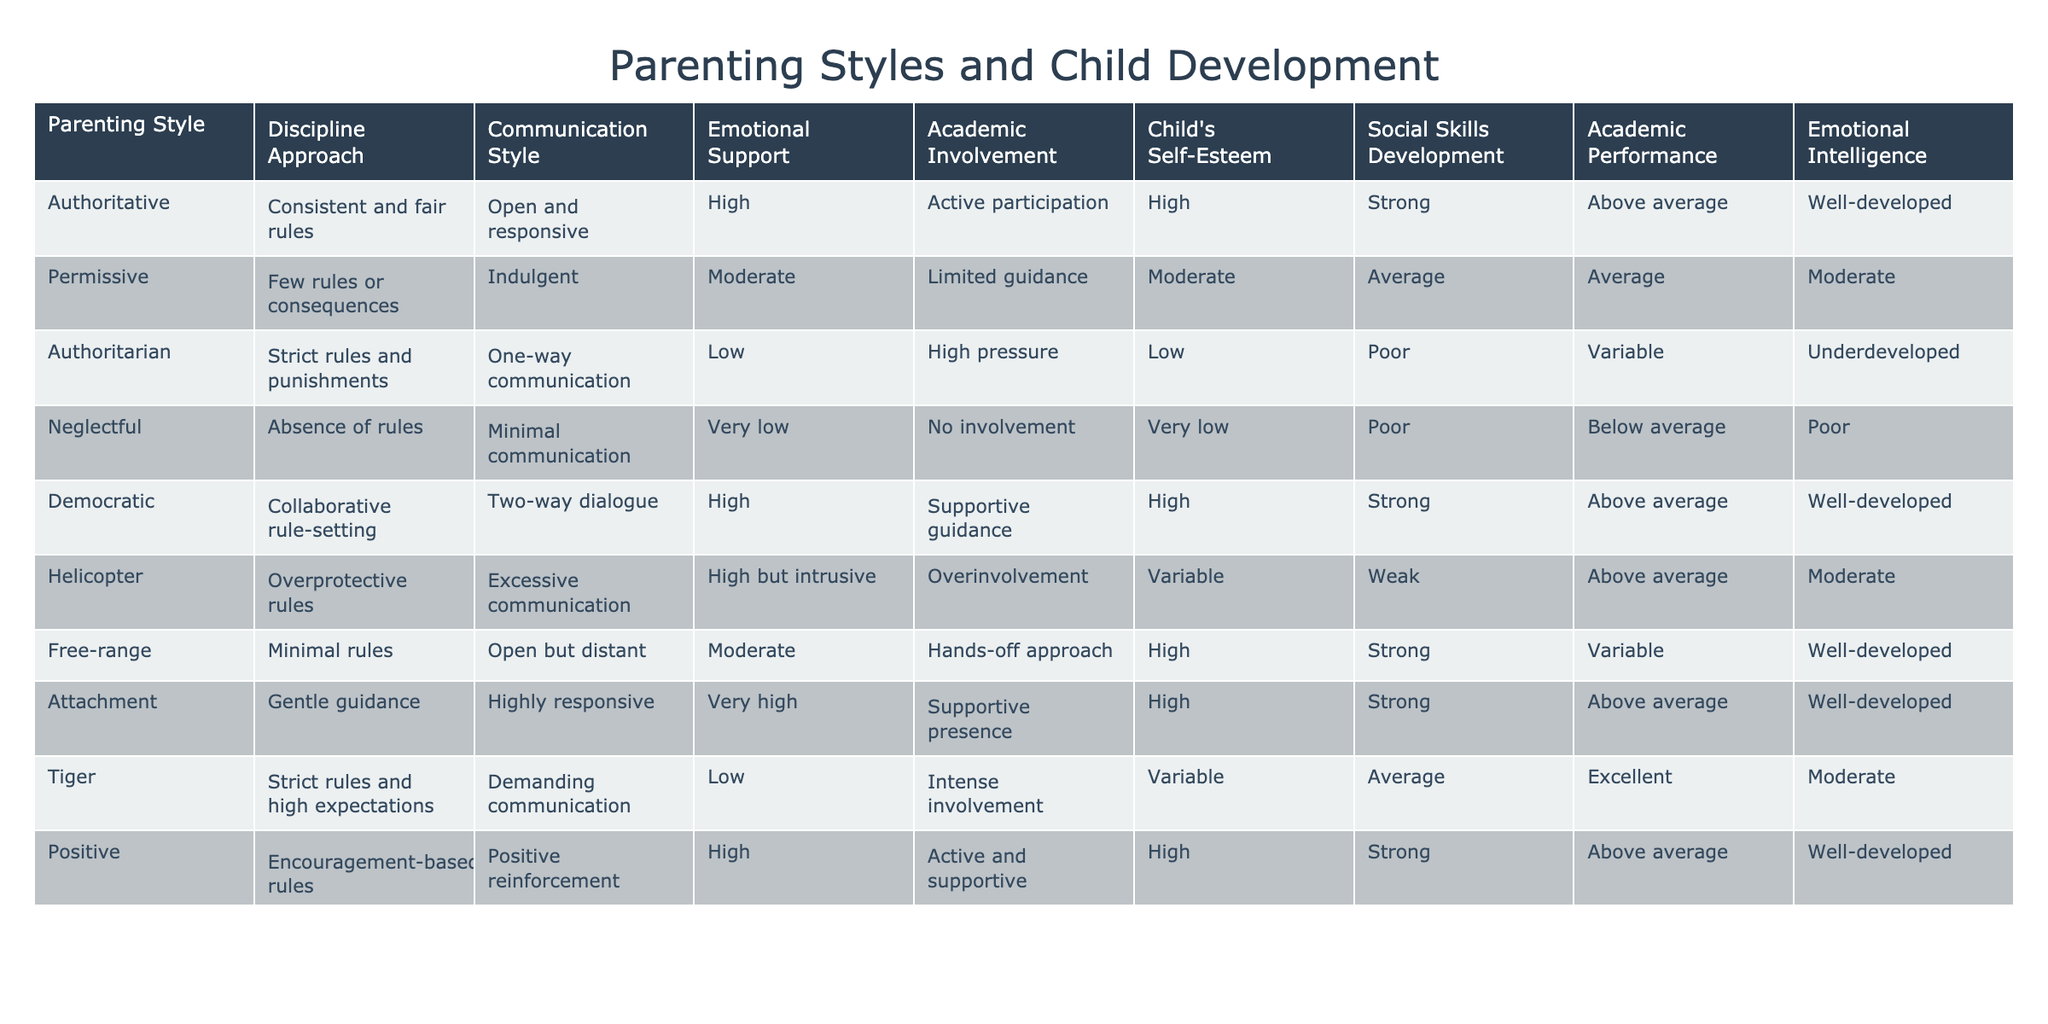What is the communication style of the authoritative parenting style? The table specifies that the communication style of authoritative parenting is "Open and responsive."
Answer: Open and responsive Which parenting style shows the highest academic performance? According to the table, the "Tiger" parenting style is associated with "Excellent" academic performance, which is the highest listed.
Answer: Excellent Is the emotional support provided by the neglectful parenting style low? The table indicates that neglectful parenting has "Very low" emotional support, thus confirming this statement as true.
Answer: Yes What are the academic involvement levels of democratic and helicopter parenting styles? Looking at the table, democratic parenting has "Supportive guidance", whereas helicopter parenting has "Overinvolvement", both indicating high levels of academic involvement. Thus, they are both engaged academically, but in different ways.
Answer: Supportive guidance and Overinvolvement Which parenting style has moderate discipline approach and leads to average social skills development? The permissive parenting style is characterized by "Few rules or consequences" in its discipline approach and it results in "Average" social skills development according to the table.
Answer: Permissive What is the average child's self-esteem score for the authoritarian and neglectful parenting styles combined? The self-esteem scores for the authoritarian and neglectful parenting styles are "Low" and "Very low" respectively. If we consider "Low" as 2 and "Very low" as 1 (on a scale where 1 is lowest and 5 is highest), the average would be (2 + 1)/2 = 1.5, corresponding to "Low".
Answer: Low Does the attachment parenting style lead to high emotional intelligence in children? The data indicates that attachment parenting leads to "Well-developed" emotional intelligence, confirming the statement is true.
Answer: Yes What is the difference in emotional support between authoritarian and democratic parenting styles? The authoritarian style has "Low" emotional support, whereas democratic parenting provides "High" emotional support. The difference therefore is High - Low = Moderate.
Answer: Moderate What is the communication style for free-range parenting compared to permissive parenting? The table shows that free-range parenting has "Open but distant" communication, while permissive parenting has "Indulgent" communication, which suggests a difference in engagement levels.
Answer: Open but distant and Indulgent 